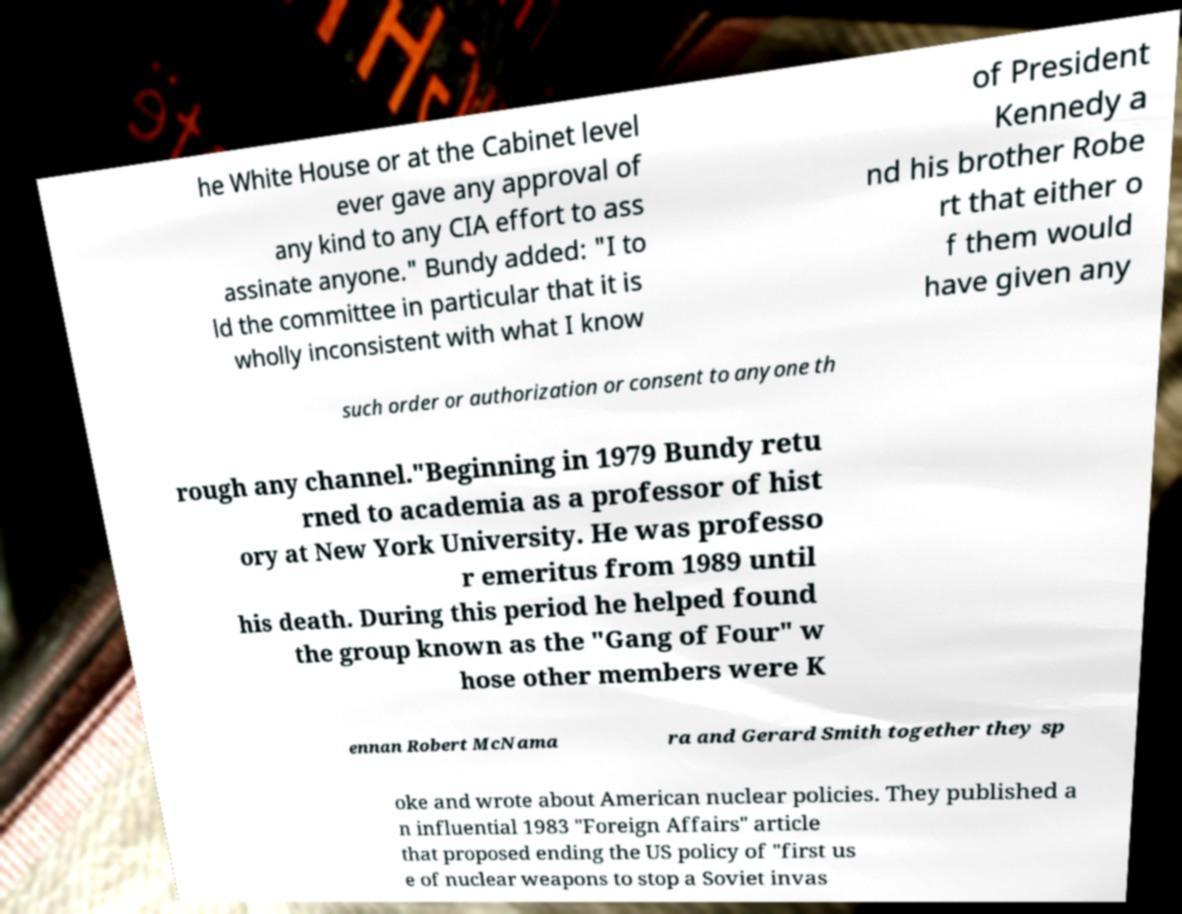For documentation purposes, I need the text within this image transcribed. Could you provide that? he White House or at the Cabinet level ever gave any approval of any kind to any CIA effort to ass assinate anyone." Bundy added: "I to ld the committee in particular that it is wholly inconsistent with what I know of President Kennedy a nd his brother Robe rt that either o f them would have given any such order or authorization or consent to anyone th rough any channel."Beginning in 1979 Bundy retu rned to academia as a professor of hist ory at New York University. He was professo r emeritus from 1989 until his death. During this period he helped found the group known as the "Gang of Four" w hose other members were K ennan Robert McNama ra and Gerard Smith together they sp oke and wrote about American nuclear policies. They published a n influential 1983 "Foreign Affairs" article that proposed ending the US policy of "first us e of nuclear weapons to stop a Soviet invas 